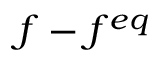Convert formula to latex. <formula><loc_0><loc_0><loc_500><loc_500>f - f ^ { e q }</formula> 